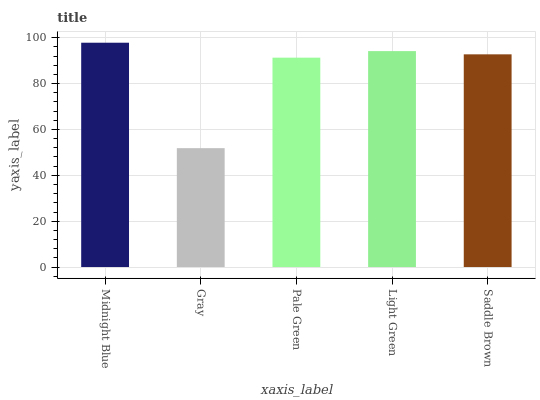Is Gray the minimum?
Answer yes or no. Yes. Is Midnight Blue the maximum?
Answer yes or no. Yes. Is Pale Green the minimum?
Answer yes or no. No. Is Pale Green the maximum?
Answer yes or no. No. Is Pale Green greater than Gray?
Answer yes or no. Yes. Is Gray less than Pale Green?
Answer yes or no. Yes. Is Gray greater than Pale Green?
Answer yes or no. No. Is Pale Green less than Gray?
Answer yes or no. No. Is Saddle Brown the high median?
Answer yes or no. Yes. Is Saddle Brown the low median?
Answer yes or no. Yes. Is Midnight Blue the high median?
Answer yes or no. No. Is Midnight Blue the low median?
Answer yes or no. No. 